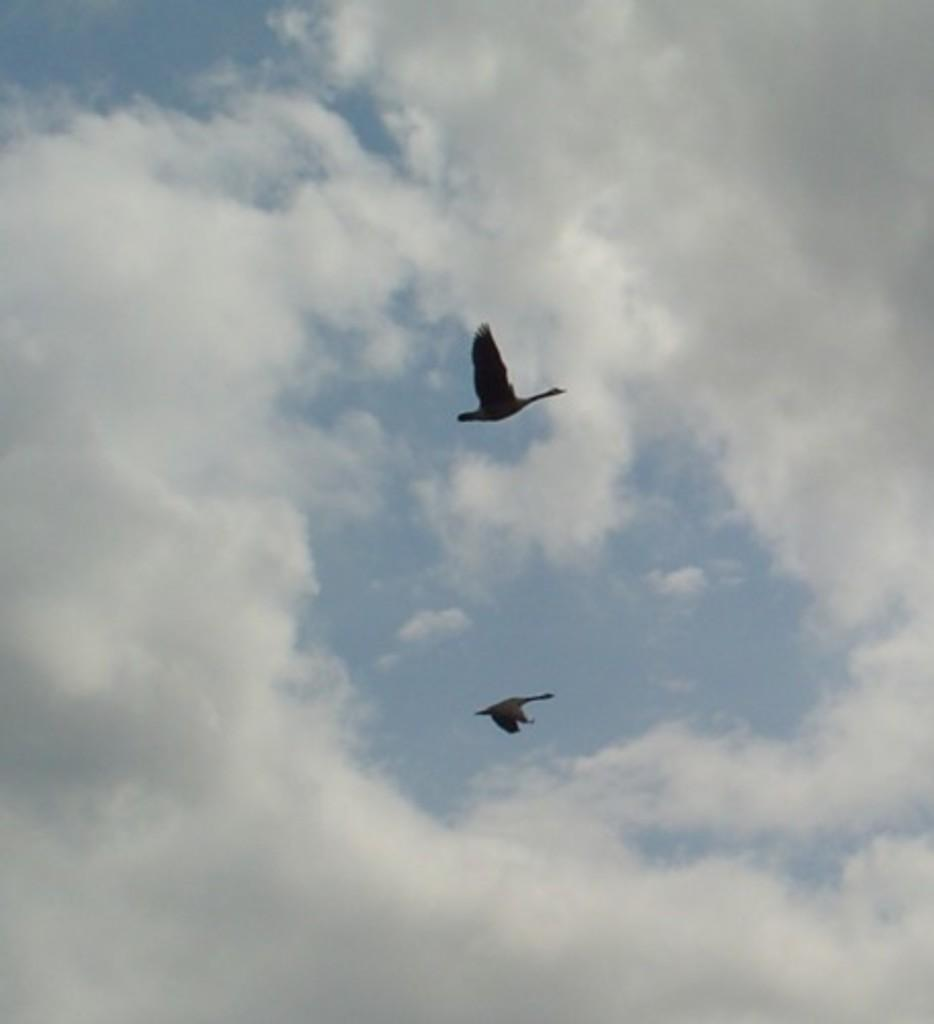How many birds are visible in the image? There are two birds in the image. What are the birds doing in the image? The birds are flying in the sky. What is the condition of the sky in the image? The sky appears to be cloudy. Where is the basket located in the image? There is no basket present in the image. What type of party is being held in the image? There is no party depicted in the image. 